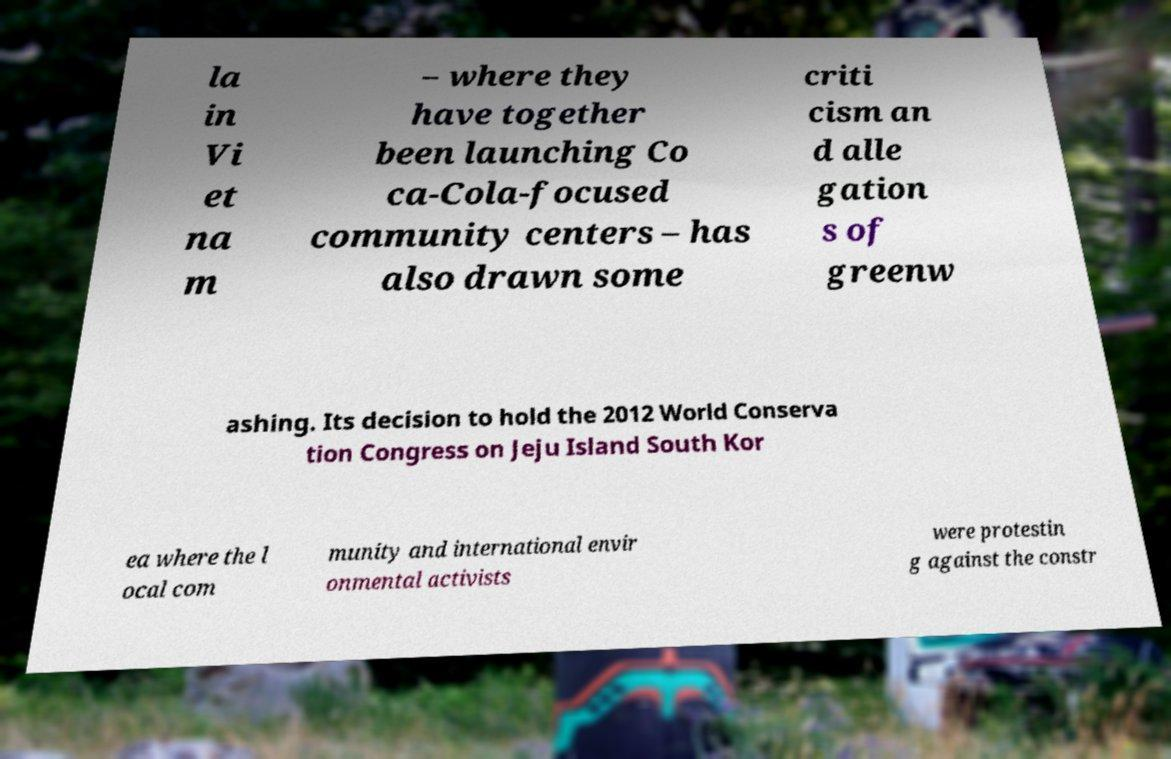Please identify and transcribe the text found in this image. la in Vi et na m – where they have together been launching Co ca-Cola-focused community centers – has also drawn some criti cism an d alle gation s of greenw ashing. Its decision to hold the 2012 World Conserva tion Congress on Jeju Island South Kor ea where the l ocal com munity and international envir onmental activists were protestin g against the constr 